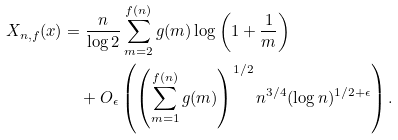<formula> <loc_0><loc_0><loc_500><loc_500>X _ { n , f } ( x ) & = \frac { n } { \log 2 } \sum _ { m = 2 } ^ { f ( n ) } g ( m ) \log \left ( 1 + \frac { 1 } { m } \right ) \\ & \quad + O _ { \epsilon } \left ( \left ( \sum _ { m = 1 } ^ { f ( n ) } g ( m ) \right ) ^ { 1 / 2 } n ^ { 3 / 4 } ( \log n ) ^ { 1 / 2 + \epsilon } \right ) .</formula> 